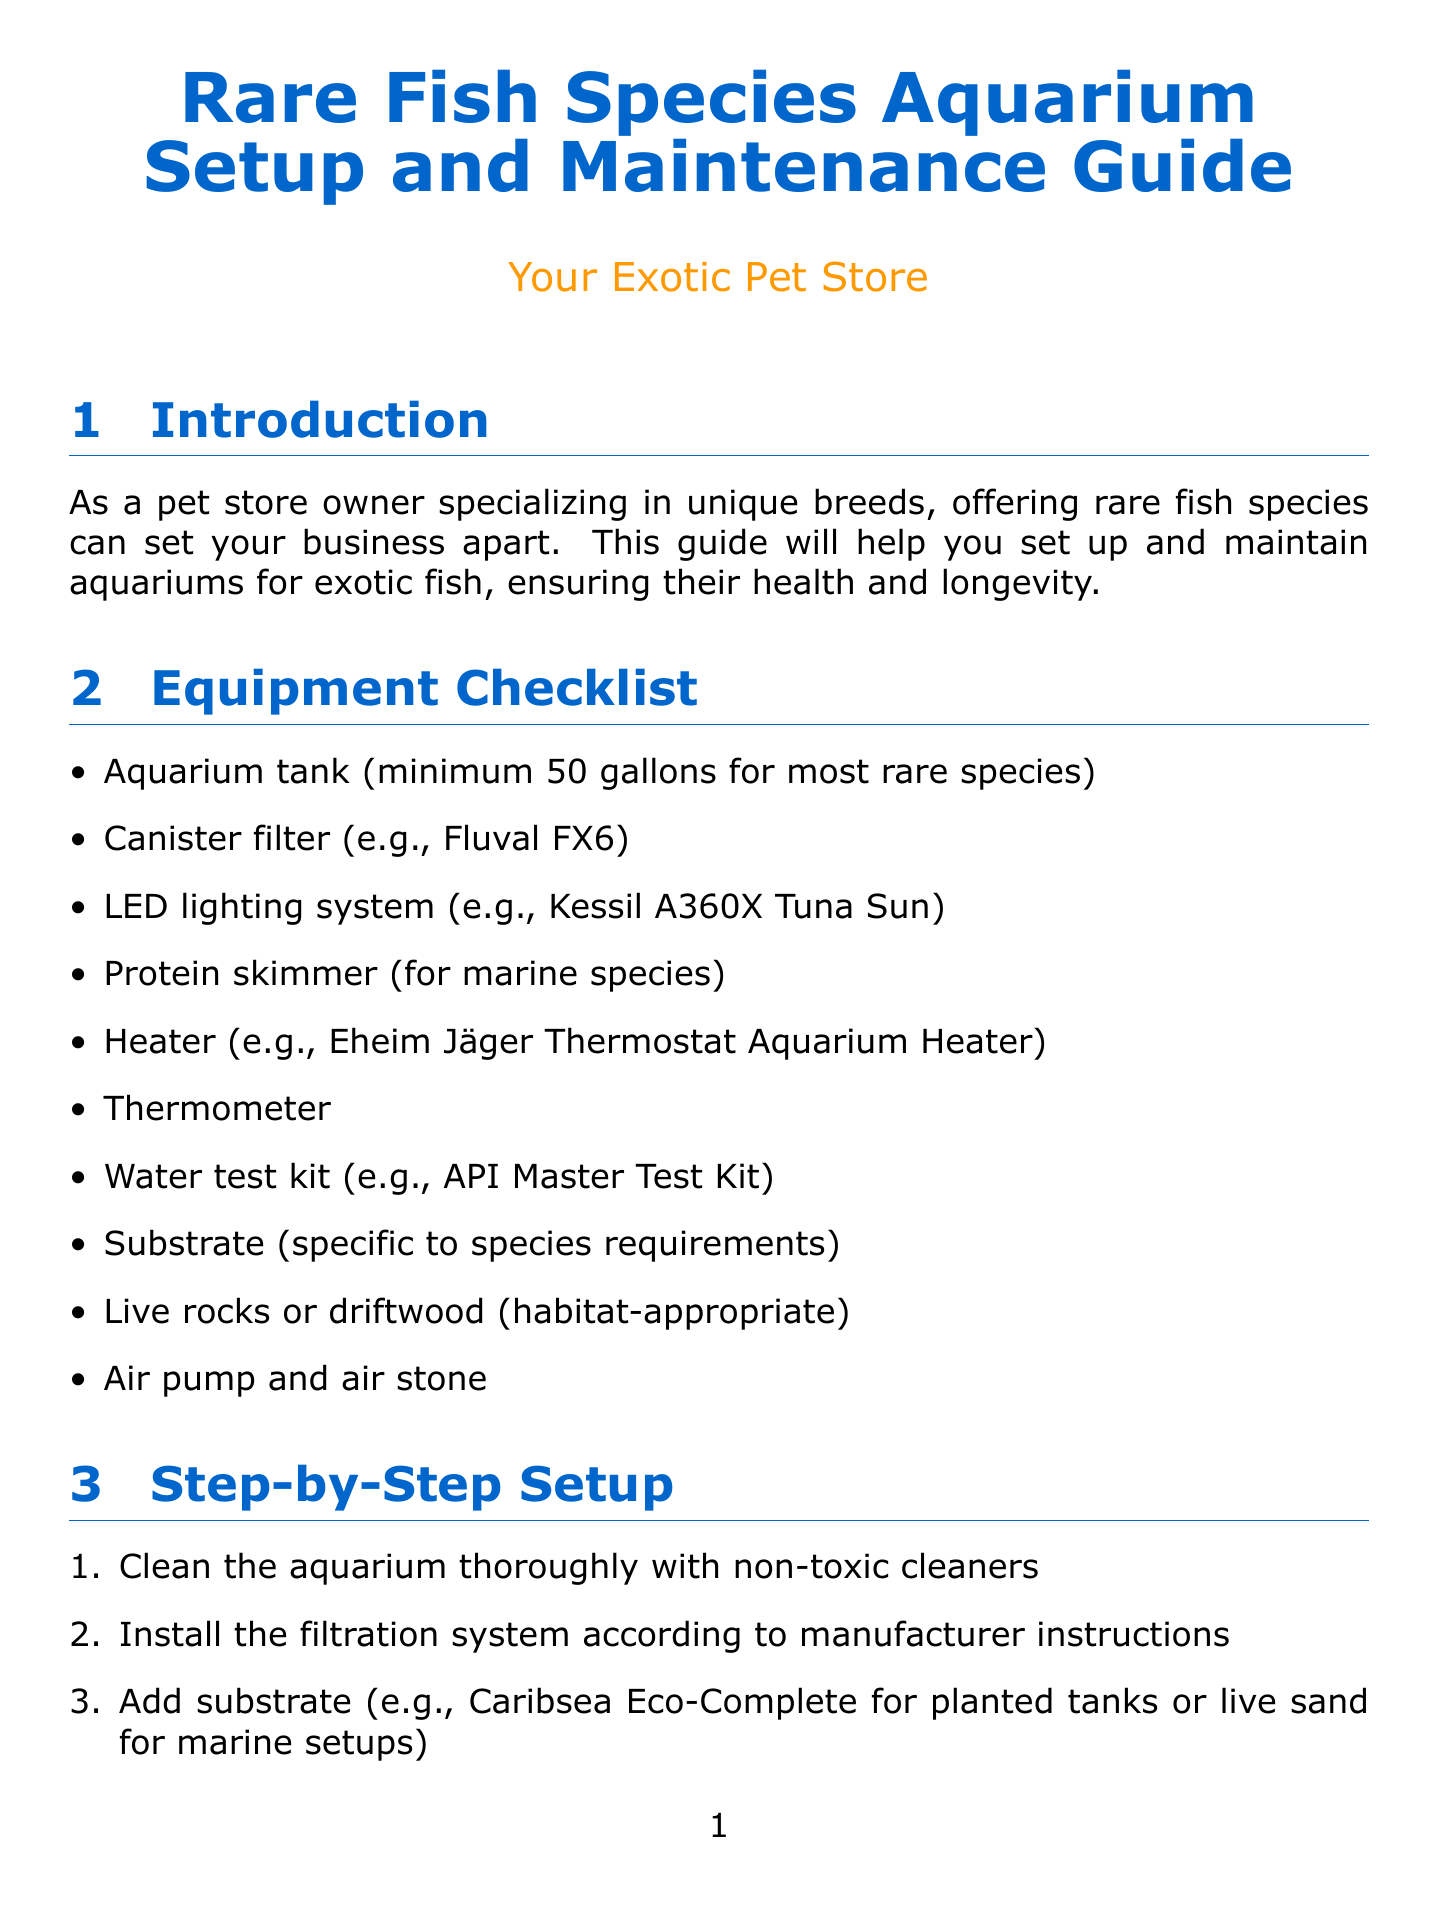What is the minimum aquarium tank size for most rare species? The document specifies that the minimum aquarium tank size is 50 gallons for most rare species.
Answer: 50 gallons What type of filter is recommended? The document lists canister filters as recommended, with the Fluval FX6 as an example.
Answer: Canister filter (e.g., Fluval FX6) What is the optimal pH level for Banggai Cardinalfish? The recommended pH level for Banggai Cardinalfish is given in the species-specific care section.
Answer: pH 8.1-8.4 How often should water changes be performed? The document states that regular water changes should be performed weekly, specifying a percentage range for changes.
Answer: 10-20% weekly What is one measure for disease prevention? The document highlights quarantining new fish as an essential disease prevention measure before introducing them to the main tank.
Answer: Quarantine new fish What type of heater is suggested in the equipment checklist? The document suggests using an Eheim Jäger Thermostat Aquarium Heater in the equipment checklist.
Answer: Eheim Jäger Thermostat Aquarium Heater How many times a day should fish be fed? The guidelines mention feeding fish small amounts 2-3 times daily rather than one large feeding.
Answer: 2-3 times daily What is the temperature range for Zebra Pleco? The care instructions in the document specify the temperature range for Zebra Pleco.
Answer: 79-86°F When should a UV sterilizer be installed? The document advises the installation of a UV sterilizer to control algae and parasites during water quality management.
Answer: To control algae and parasites 